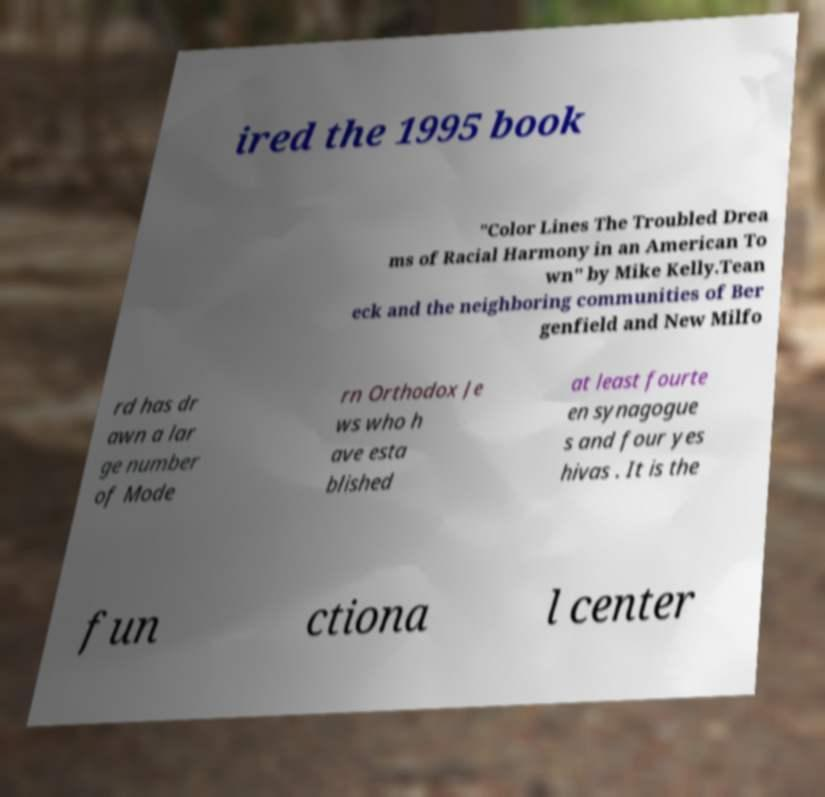Could you extract and type out the text from this image? ired the 1995 book "Color Lines The Troubled Drea ms of Racial Harmony in an American To wn" by Mike Kelly.Tean eck and the neighboring communities of Ber genfield and New Milfo rd has dr awn a lar ge number of Mode rn Orthodox Je ws who h ave esta blished at least fourte en synagogue s and four yes hivas . It is the fun ctiona l center 